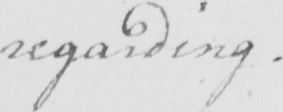Please transcribe the handwritten text in this image. regarding . 